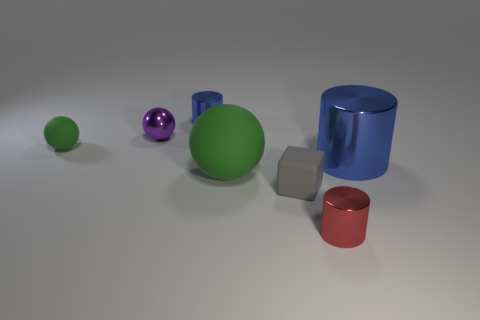Is there a small gray object made of the same material as the big ball?
Offer a terse response. Yes. Are there more objects that are in front of the big green matte thing than blue metal cylinders behind the tiny purple ball?
Provide a succinct answer. Yes. How big is the gray rubber block?
Provide a short and direct response. Small. What shape is the small metallic thing that is in front of the big metal object?
Keep it short and to the point. Cylinder. Does the big blue shiny object have the same shape as the gray thing?
Give a very brief answer. No. Is the number of tiny purple things that are to the left of the small purple metallic sphere the same as the number of large red matte cylinders?
Give a very brief answer. Yes. The gray rubber thing has what shape?
Keep it short and to the point. Cube. Are there any other things that have the same color as the big shiny object?
Make the answer very short. Yes. There is a green matte ball on the right side of the tiny blue metallic thing; is it the same size as the green object that is left of the big green rubber sphere?
Provide a succinct answer. No. There is a matte thing behind the blue shiny cylinder to the right of the big green object; what is its shape?
Your response must be concise. Sphere. 